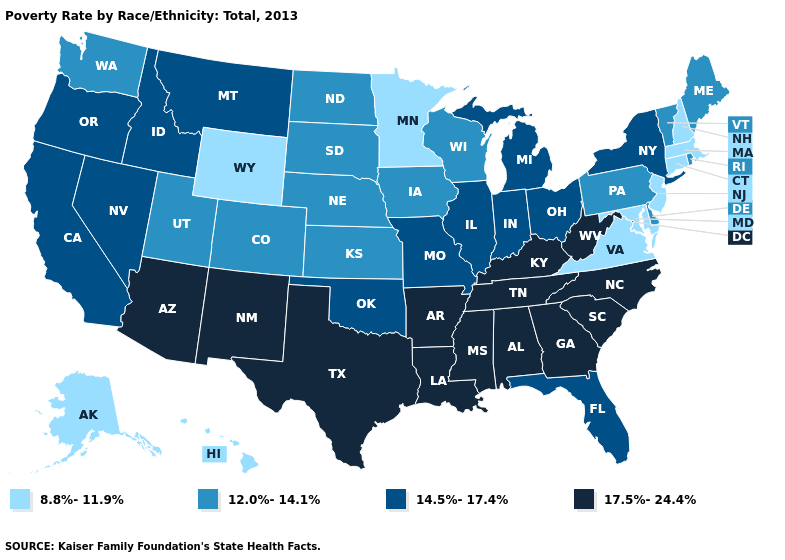Does the first symbol in the legend represent the smallest category?
Short answer required. Yes. Does the map have missing data?
Quick response, please. No. Among the states that border Montana , which have the lowest value?
Concise answer only. Wyoming. Name the states that have a value in the range 8.8%-11.9%?
Quick response, please. Alaska, Connecticut, Hawaii, Maryland, Massachusetts, Minnesota, New Hampshire, New Jersey, Virginia, Wyoming. What is the value of Washington?
Answer briefly. 12.0%-14.1%. Does Wyoming have the lowest value in the USA?
Be succinct. Yes. Does West Virginia have the lowest value in the USA?
Give a very brief answer. No. What is the highest value in the West ?
Be succinct. 17.5%-24.4%. Among the states that border Montana , does Idaho have the highest value?
Keep it brief. Yes. What is the lowest value in states that border Pennsylvania?
Be succinct. 8.8%-11.9%. What is the lowest value in states that border New Mexico?
Concise answer only. 12.0%-14.1%. Name the states that have a value in the range 8.8%-11.9%?
Answer briefly. Alaska, Connecticut, Hawaii, Maryland, Massachusetts, Minnesota, New Hampshire, New Jersey, Virginia, Wyoming. What is the lowest value in states that border Georgia?
Concise answer only. 14.5%-17.4%. How many symbols are there in the legend?
Keep it brief. 4. Is the legend a continuous bar?
Keep it brief. No. 